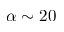Convert formula to latex. <formula><loc_0><loc_0><loc_500><loc_500>\alpha \sim 2 0</formula> 